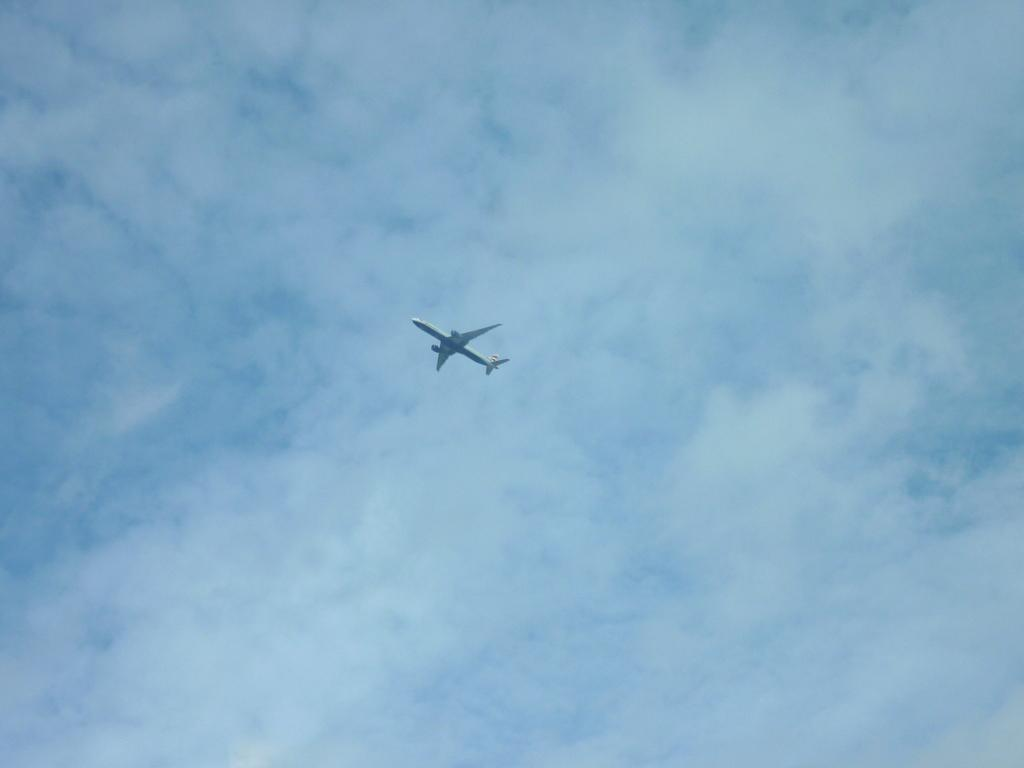What is the color of the airplane in the image? The airplane is white in the image. Where is the airplane located in the image? The airplane is in the center of the image. What can be seen in the background of the image? There is sky visible in the background of the image. What is present in the sky? Clouds are present in the sky. What type of lipstick is the airplane wearing in the image? There is no lipstick or any indication of makeup on the airplane in the image. What relation does the airplane have with the clouds in the image? The airplane is not related to the clouds in the image; they are simply two separate elements in the scene. 